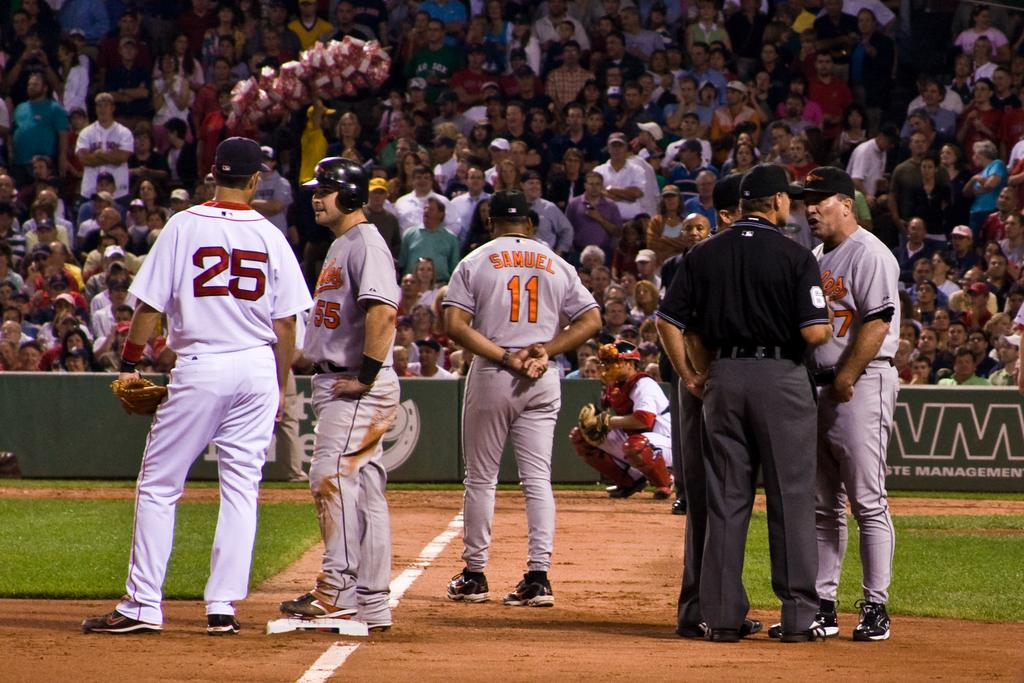<image>
Summarize the visual content of the image. A baseball game with players on the field 25, 55, and Samuel 11 